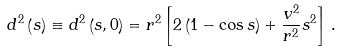Convert formula to latex. <formula><loc_0><loc_0><loc_500><loc_500>d ^ { 2 } \left ( s \right ) \equiv d ^ { 2 } \left ( s , 0 \right ) = r ^ { 2 } \left [ 2 \left ( 1 - \cos s \right ) + \frac { v ^ { 2 } } { r ^ { 2 } } s ^ { 2 } \right ] \, .</formula> 